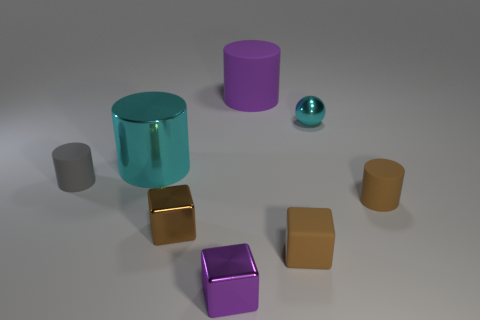What size is the cylinder that is the same color as the tiny matte block?
Keep it short and to the point. Small. What is the shape of the cyan thing that is the same material as the tiny cyan sphere?
Offer a terse response. Cylinder. Are there fewer cylinders that are right of the large rubber cylinder than tiny brown objects that are on the left side of the tiny cyan metallic sphere?
Ensure brevity in your answer.  Yes. What number of small objects are cylinders or matte blocks?
Ensure brevity in your answer.  3. Do the large object that is on the left side of the purple shiny block and the small metal thing that is behind the small gray cylinder have the same shape?
Give a very brief answer. No. How big is the cyan shiny object in front of the tiny object behind the cylinder that is to the left of the cyan cylinder?
Provide a succinct answer. Large. How big is the cylinder to the right of the large purple rubber cylinder?
Keep it short and to the point. Small. What is the small gray thing to the left of the small cyan metallic thing made of?
Keep it short and to the point. Rubber. What number of red things are large rubber objects or cylinders?
Your response must be concise. 0. Does the tiny purple block have the same material as the cyan object to the right of the big shiny cylinder?
Give a very brief answer. Yes. 